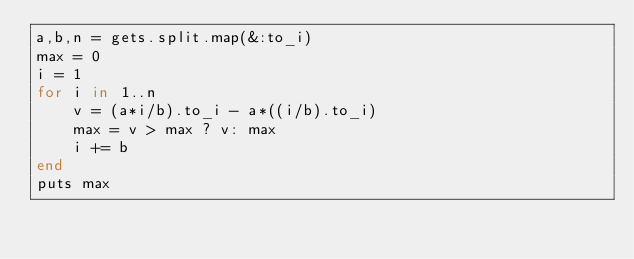Convert code to text. <code><loc_0><loc_0><loc_500><loc_500><_Ruby_>a,b,n = gets.split.map(&:to_i)
max = 0
i = 1
for i in 1..n
    v = (a*i/b).to_i - a*((i/b).to_i)
    max = v > max ? v: max
    i += b
end
puts max
</code> 